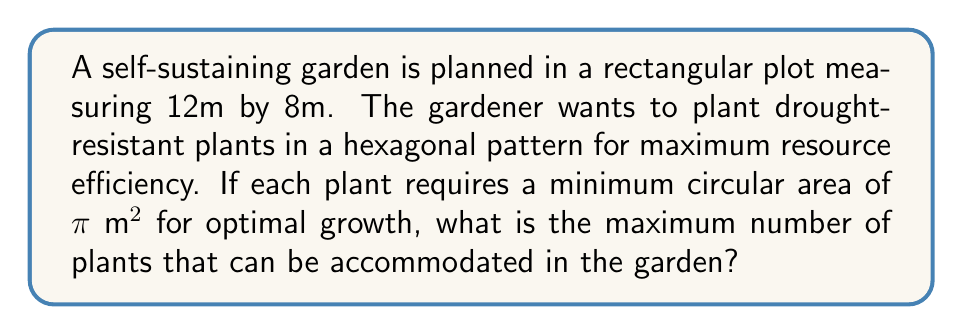Could you help me with this problem? To solve this problem, we'll follow these steps:

1) First, we need to calculate the area of the garden:
   $A_{garden} = 12m \times 8m = 96$ m²

2) Each plant requires a circular area of $\pi$ m². In a hexagonal pattern, the most efficient packing density is achieved when the circles are arranged in a honeycomb-like structure. The packing density for this arrangement is:

   $\eta = \frac{\pi}{2\sqrt{3}} \approx 0.9069$

3) This means that the effective area needed per plant in the hexagonal arrangement is:

   $A_{effective} = \frac{\pi}{\eta} = \frac{\pi}{\frac{\pi}{2\sqrt{3}}} = 2\sqrt{3}$ m²

4) Now, we can calculate the maximum number of plants by dividing the total garden area by the effective area per plant:

   $N_{max} = \frac{A_{garden}}{A_{effective}} = \frac{96}{2\sqrt{3}}$

5) Simplifying:
   $N_{max} = \frac{96}{2\sqrt{3}} = \frac{48}{\sqrt{3}} = 16\sqrt{3} \approx 27.71$

6) Since we can't have a fractional number of plants, we round down to the nearest whole number.

[asy]
unitsize(10cm);
fill((0,0)--(1,0)--(1.5,0.866)--(1,1.732)--(0,1.732)--(-0.5,0.866)--cycle,gray(0.8));
draw(circle((0,0),1));
draw(circle((1,0),1));
draw(circle((0.5,0.866),1));
draw(circle((1.5,0.866),1));
draw(circle((0,1.732),1));
draw(circle((1,1.732),1));
label("Hexagonal packing", (0.5,2.3));
[/asy]
Answer: 27 plants 